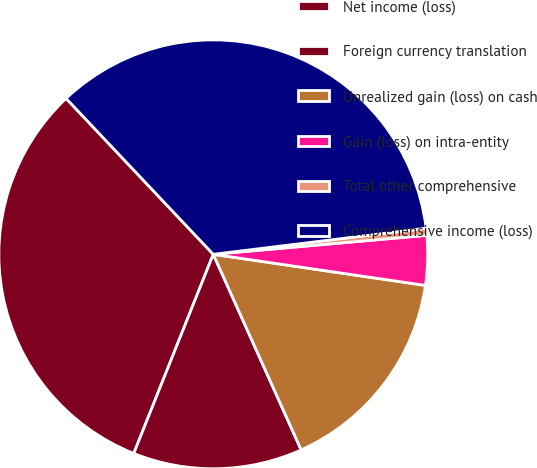Convert chart to OTSL. <chart><loc_0><loc_0><loc_500><loc_500><pie_chart><fcel>Net income (loss)<fcel>Foreign currency translation<fcel>Unrealized gain (loss) on cash<fcel>Gain (loss) on intra-entity<fcel>Total other comprehensive<fcel>Comprehensive income (loss)<nl><fcel>31.91%<fcel>12.77%<fcel>15.96%<fcel>3.73%<fcel>0.53%<fcel>35.1%<nl></chart> 